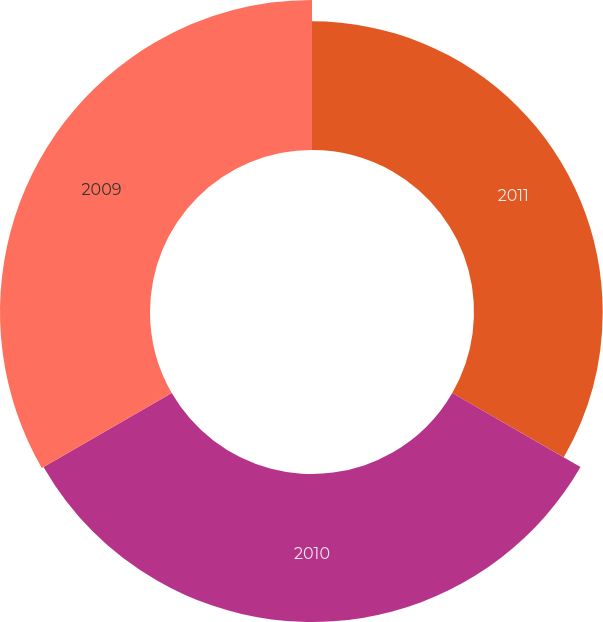Convert chart to OTSL. <chart><loc_0><loc_0><loc_500><loc_500><pie_chart><fcel>2011<fcel>2010<fcel>2009<nl><fcel>30.16%<fcel>34.69%<fcel>35.15%<nl></chart> 